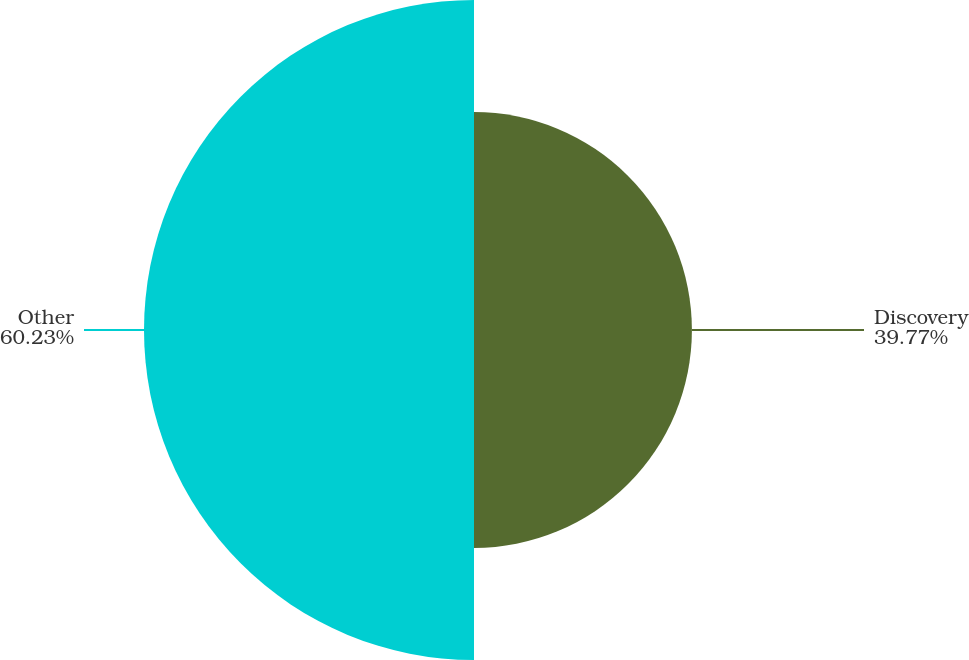Convert chart to OTSL. <chart><loc_0><loc_0><loc_500><loc_500><pie_chart><fcel>Discovery<fcel>Other<nl><fcel>39.77%<fcel>60.23%<nl></chart> 